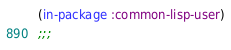<code> <loc_0><loc_0><loc_500><loc_500><_Lisp_>(in-package :common-lisp-user)
;;;</code> 